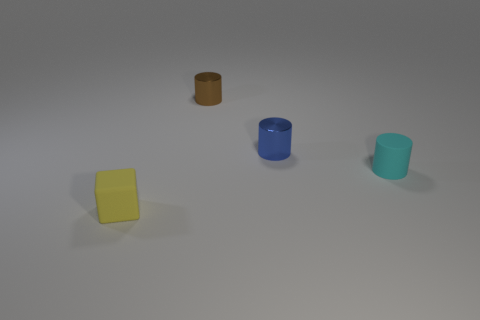Add 1 small blue rubber spheres. How many objects exist? 5 Subtract all blocks. How many objects are left? 3 Subtract 0 green blocks. How many objects are left? 4 Subtract all tiny yellow matte spheres. Subtract all small shiny cylinders. How many objects are left? 2 Add 1 brown metal objects. How many brown metal objects are left? 2 Add 2 small gray metallic cylinders. How many small gray metallic cylinders exist? 2 